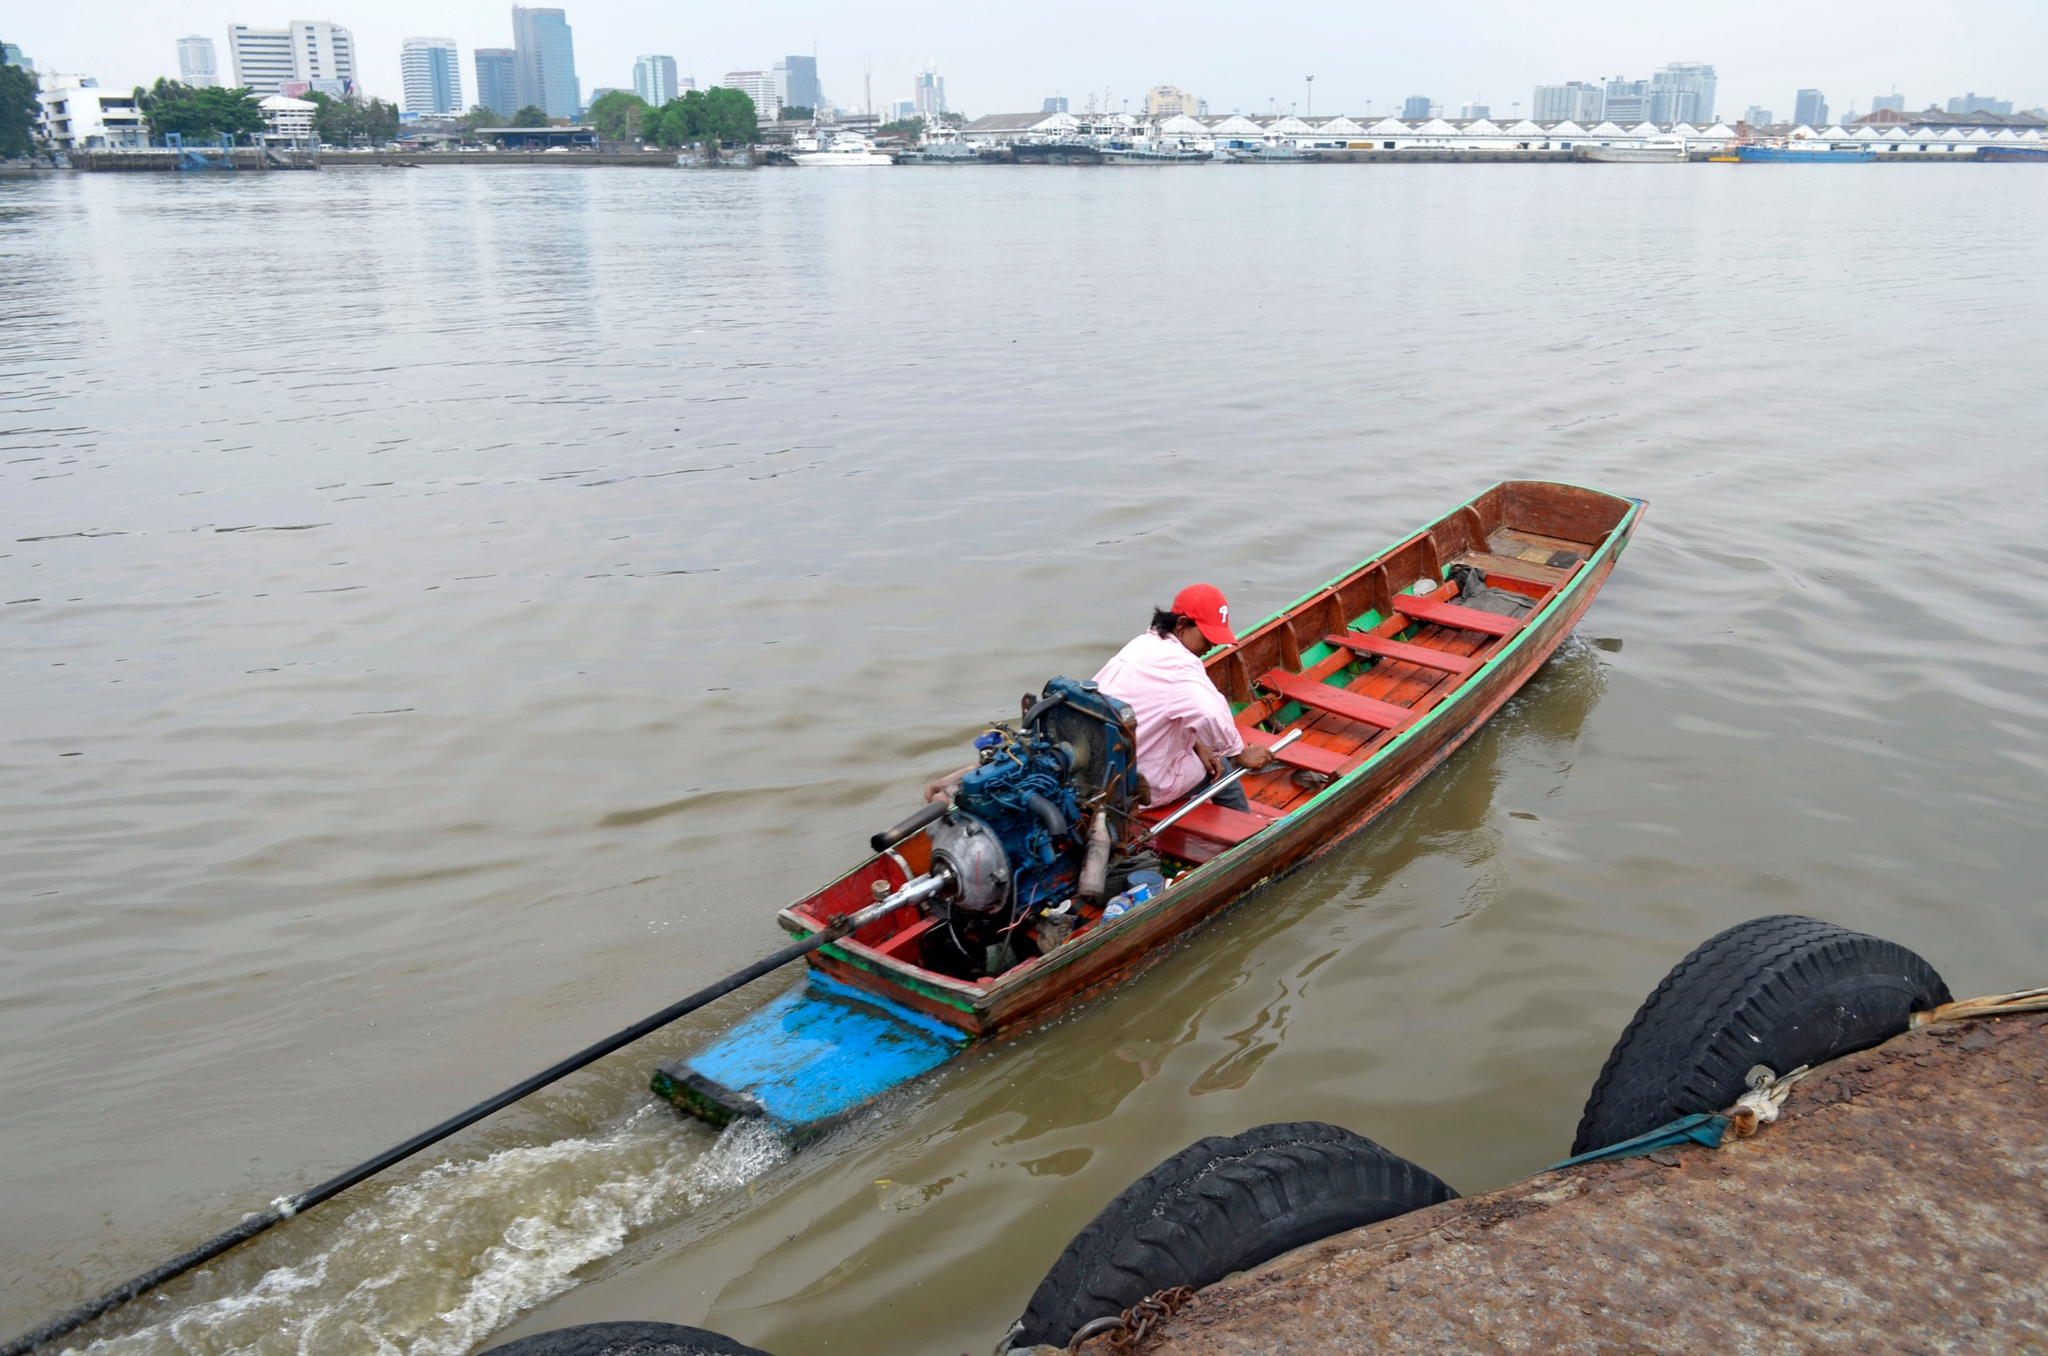Suppose an unexpected historical artifact is discovered along the riverbank. What could it be, and what stories might it tell? Suppose an unexpected historical artifact is discovered along the riverbank—a beautifully ornate, ancient chest covered in intricate carvings and bound with rusted yet sturdy metal. Inside, the chest contains old maps, mysterious scrolls written in a forgotten language, and weathered relics from a bygone era.

One scroll tells the tale of a grand civilization that once thrived along the river, ruled by enlightened leaders who revered the flowing waters as sacred. Their society was advanced in art, science, and culture, and the river was not just a lifeline, but a revered deity. The maps detail lost cities and hidden treasures believed to be located at various points along the river.

Other relics in the chest include beautifully crafted jewelry, possibly worn by nobility, and tools fashioned from metals and stones that suggest a mastery of craft and trade. The stories within these artifacts paint a picture of a people deeply connected to the river, whose legacy, though forgotten by many, remains etched into the landscape and whispers through time on the river’s currents. 